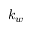<formula> <loc_0><loc_0><loc_500><loc_500>k _ { w }</formula> 